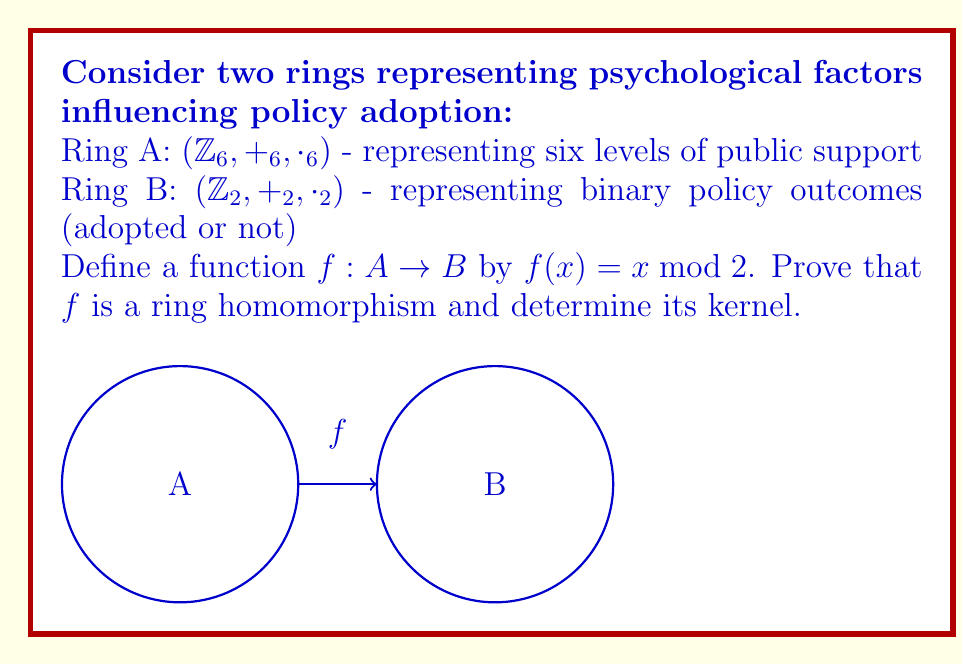Help me with this question. To prove that $f$ is a ring homomorphism, we need to show that it preserves both addition and multiplication:

1. Preservation of addition:
   For any $a, b \in A$, we need to show $f(a +_6 b) = f(a) +_2 f(b)$
   
   Let $a, b \in \mathbb{Z}_6$. Then:
   $f(a +_6 b) = (a +_6 b) \bmod 2 = ((a \bmod 2) + (b \bmod 2)) \bmod 2 = f(a) +_2 f(b)$

2. Preservation of multiplication:
   For any $a, b \in A$, we need to show $f(a \cdot_6 b) = f(a) \cdot_2 f(b)$
   
   Let $a, b \in \mathbb{Z}_6$. Then:
   $f(a \cdot_6 b) = (a \cdot_6 b) \bmod 2 = ((a \bmod 2) \cdot (b \bmod 2)) \bmod 2 = f(a) \cdot_2 f(b)$

3. Preservation of identity elements:
   $f(0_A) = 0 \bmod 2 = 0_B$
   $f(1_A) = 1 \bmod 2 = 1_B$

Therefore, $f$ is a ring homomorphism.

To determine the kernel of $f$:
$\ker(f) = \{x \in A | f(x) = 0_B\} = \{x \in \mathbb{Z}_6 | x \bmod 2 = 0\} = \{0, 2, 4\}$

This kernel represents the psychological factors that result in policy non-adoption.
Answer: $f$ is a ring homomorphism with $\ker(f) = \{0, 2, 4\}$ 